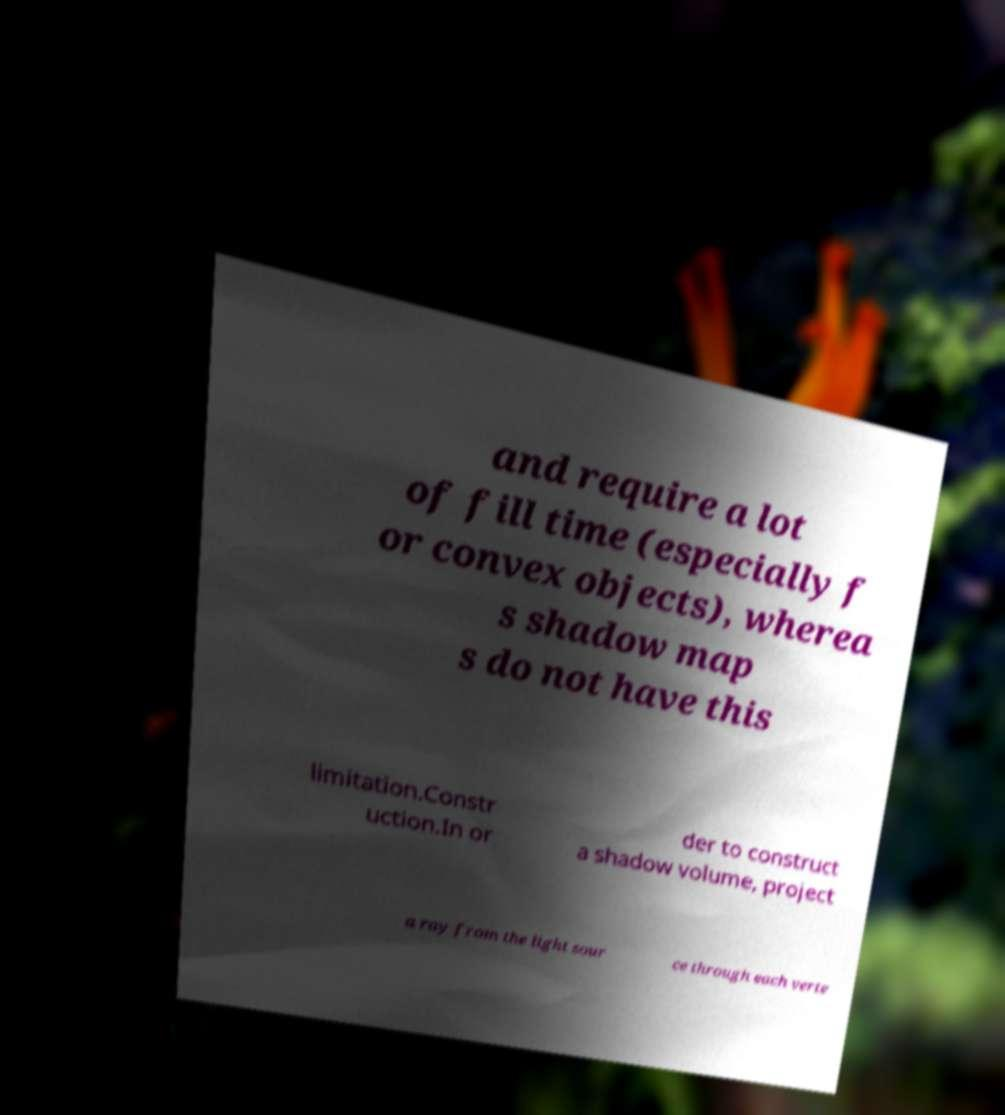I need the written content from this picture converted into text. Can you do that? and require a lot of fill time (especially f or convex objects), wherea s shadow map s do not have this limitation.Constr uction.In or der to construct a shadow volume, project a ray from the light sour ce through each verte 